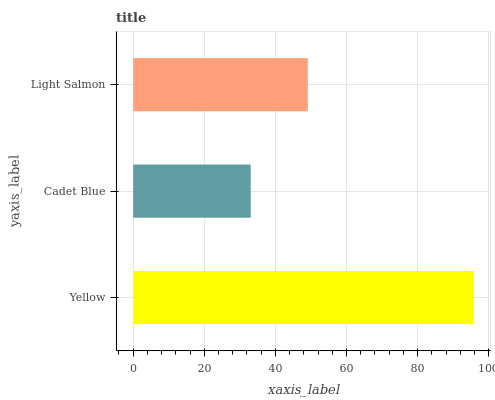Is Cadet Blue the minimum?
Answer yes or no. Yes. Is Yellow the maximum?
Answer yes or no. Yes. Is Light Salmon the minimum?
Answer yes or no. No. Is Light Salmon the maximum?
Answer yes or no. No. Is Light Salmon greater than Cadet Blue?
Answer yes or no. Yes. Is Cadet Blue less than Light Salmon?
Answer yes or no. Yes. Is Cadet Blue greater than Light Salmon?
Answer yes or no. No. Is Light Salmon less than Cadet Blue?
Answer yes or no. No. Is Light Salmon the high median?
Answer yes or no. Yes. Is Light Salmon the low median?
Answer yes or no. Yes. Is Yellow the high median?
Answer yes or no. No. Is Cadet Blue the low median?
Answer yes or no. No. 